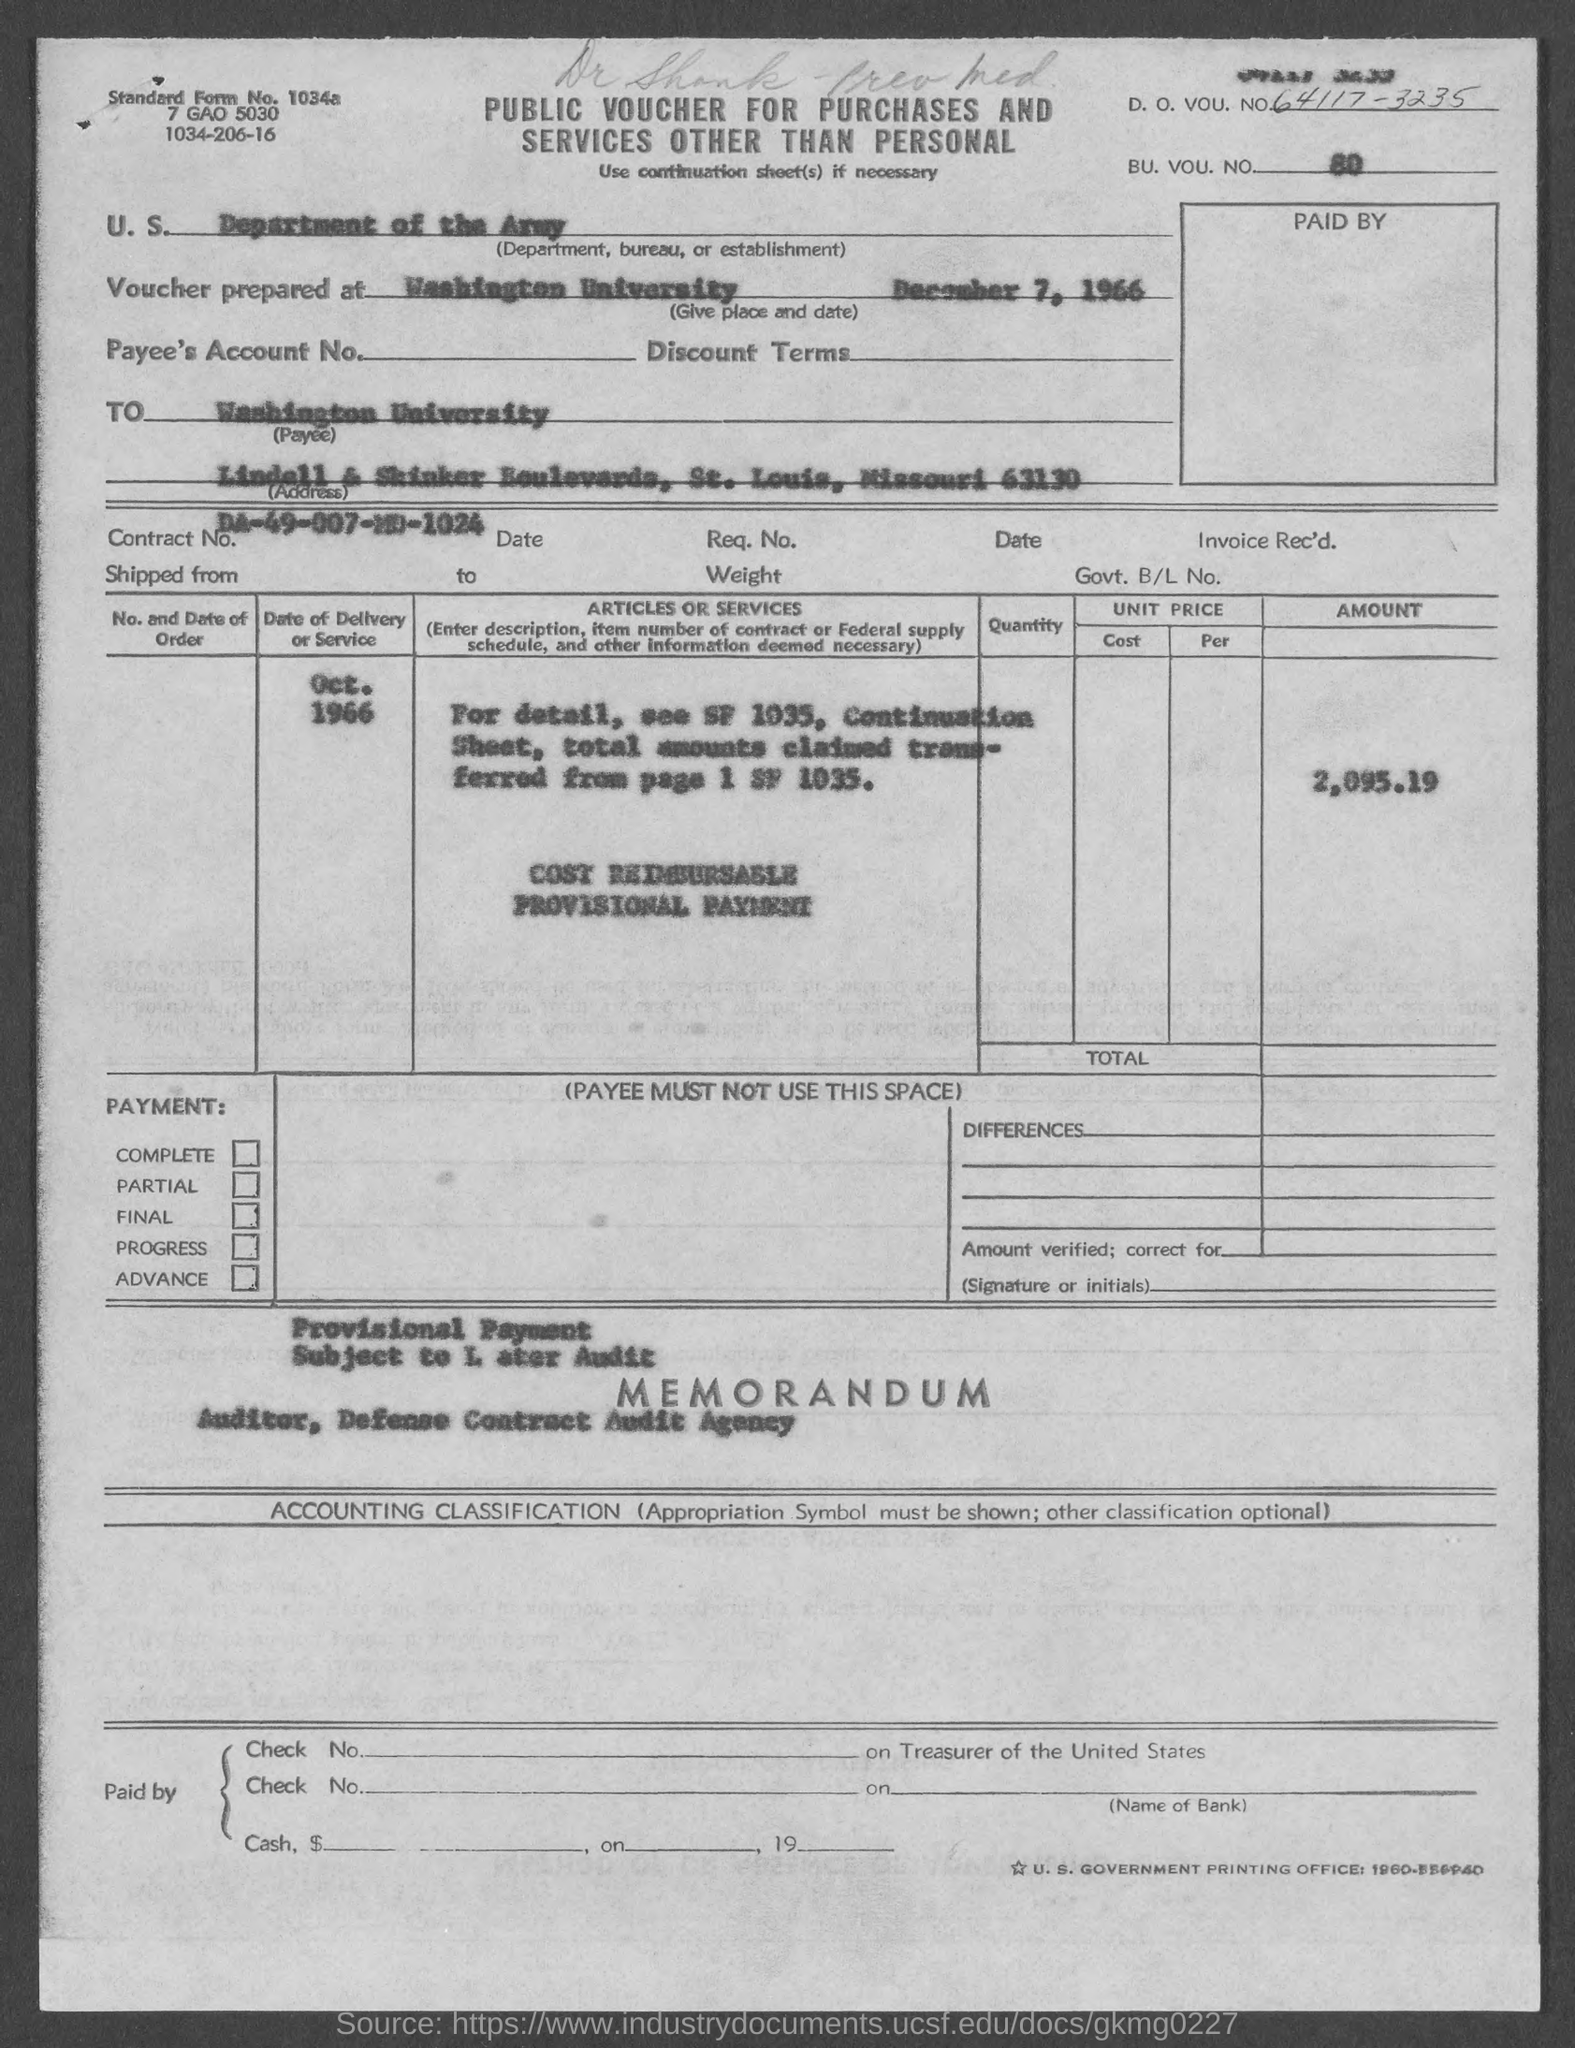What is the D. O. Vou. No. given in the voucher?
Give a very brief answer. 64117-3235. What is the BU. VOU. NO. mentioned in the voucher?
Offer a terse response. 80. What is the U.S. Department, Bureau, or Establishment given in the voucher?
Offer a very short reply. DEPARTMENT OF THE ARMY. What is the place & date of the voucher prepared?
Keep it short and to the point. Washington university. DECEMBER 7, 1966. What is the Payee name given in the voucher?
Make the answer very short. Washington university. What is the Contract No. given in the voucher?
Provide a succinct answer. DA-49-007-MD-1024. What is the total amount mentioned in the voucher?
Give a very brief answer. 2,095.19. What is the Standard Form No. given in the document?
Offer a terse response. 1034a. What type of voucher is given here?
Give a very brief answer. PUBLIC VOUCHER FOR PURCHASES AND SERVICES OTHER THAN PERSONAL. 